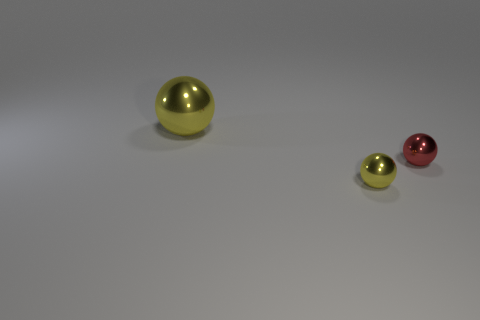Please estimate the ratio of the sizes of the spheres. Observing the image, the largest sphere appears to be roughly twice the diameter of the medium-sized sphere, and the medium sphere seems to be about twice the diameter of the smallest one. This suggests a size ratio of approximately 1:2 between consecutive spheres. Could you guess what material the spheres might be made of? Based on the reflection and sheen visible on the spheres, they could possibly be made of a polished metal or a metallic-finish plastic. The exact material, however, would be difficult to ascertain without further information or a closer inspection. 